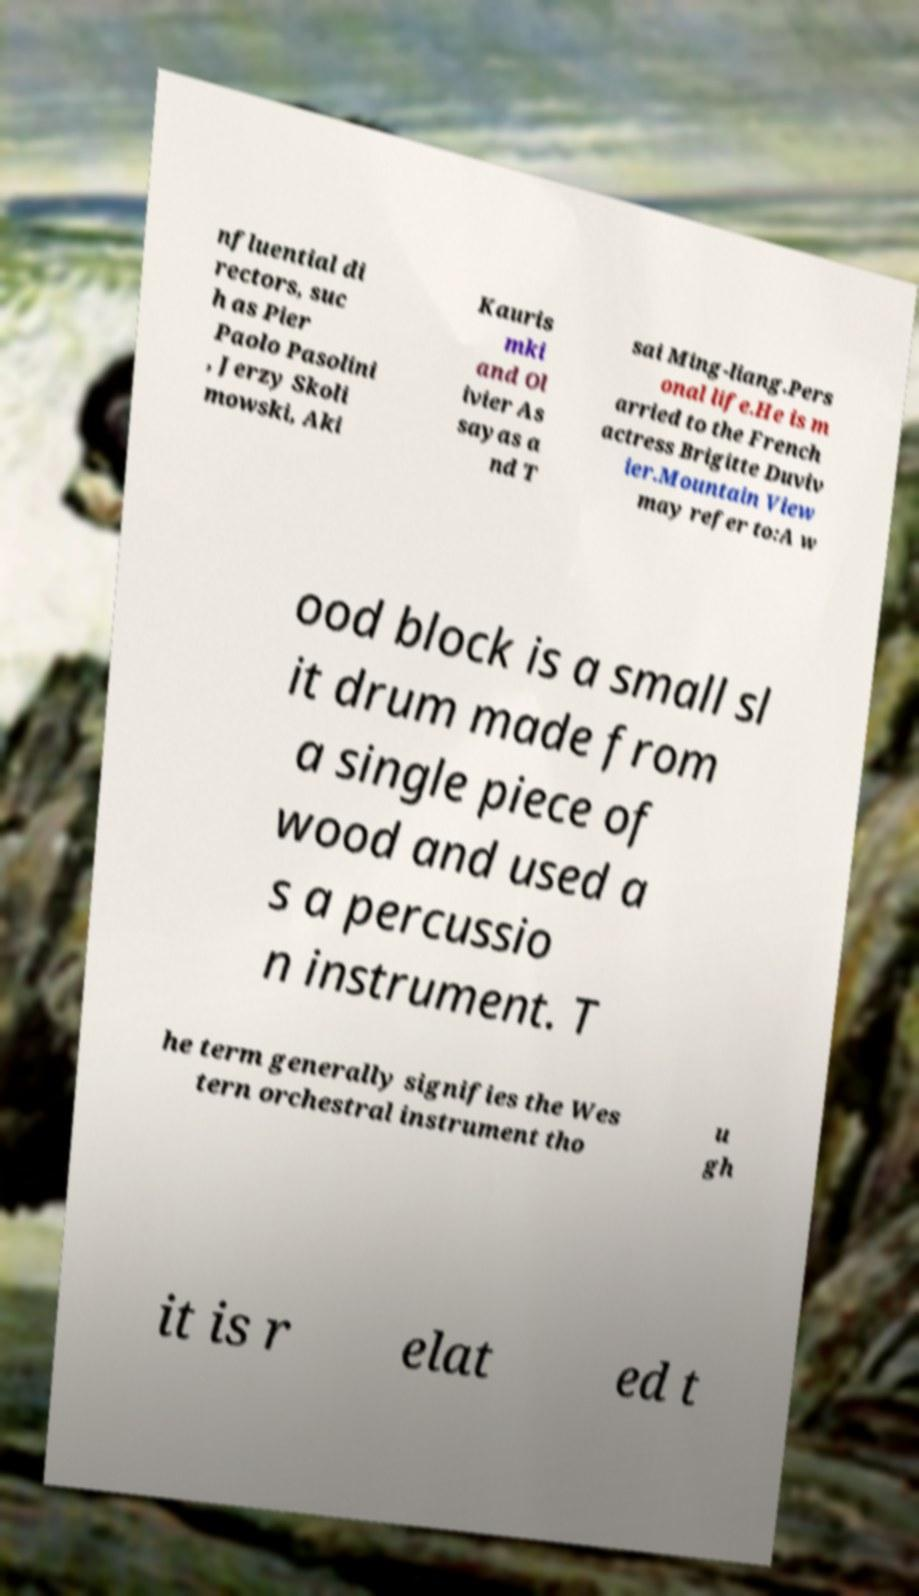For documentation purposes, I need the text within this image transcribed. Could you provide that? nfluential di rectors, suc h as Pier Paolo Pasolini , Jerzy Skoli mowski, Aki Kauris mki and Ol ivier As sayas a nd T sai Ming-liang.Pers onal life.He is m arried to the French actress Brigitte Duviv ier.Mountain View may refer to:A w ood block is a small sl it drum made from a single piece of wood and used a s a percussio n instrument. T he term generally signifies the Wes tern orchestral instrument tho u gh it is r elat ed t 